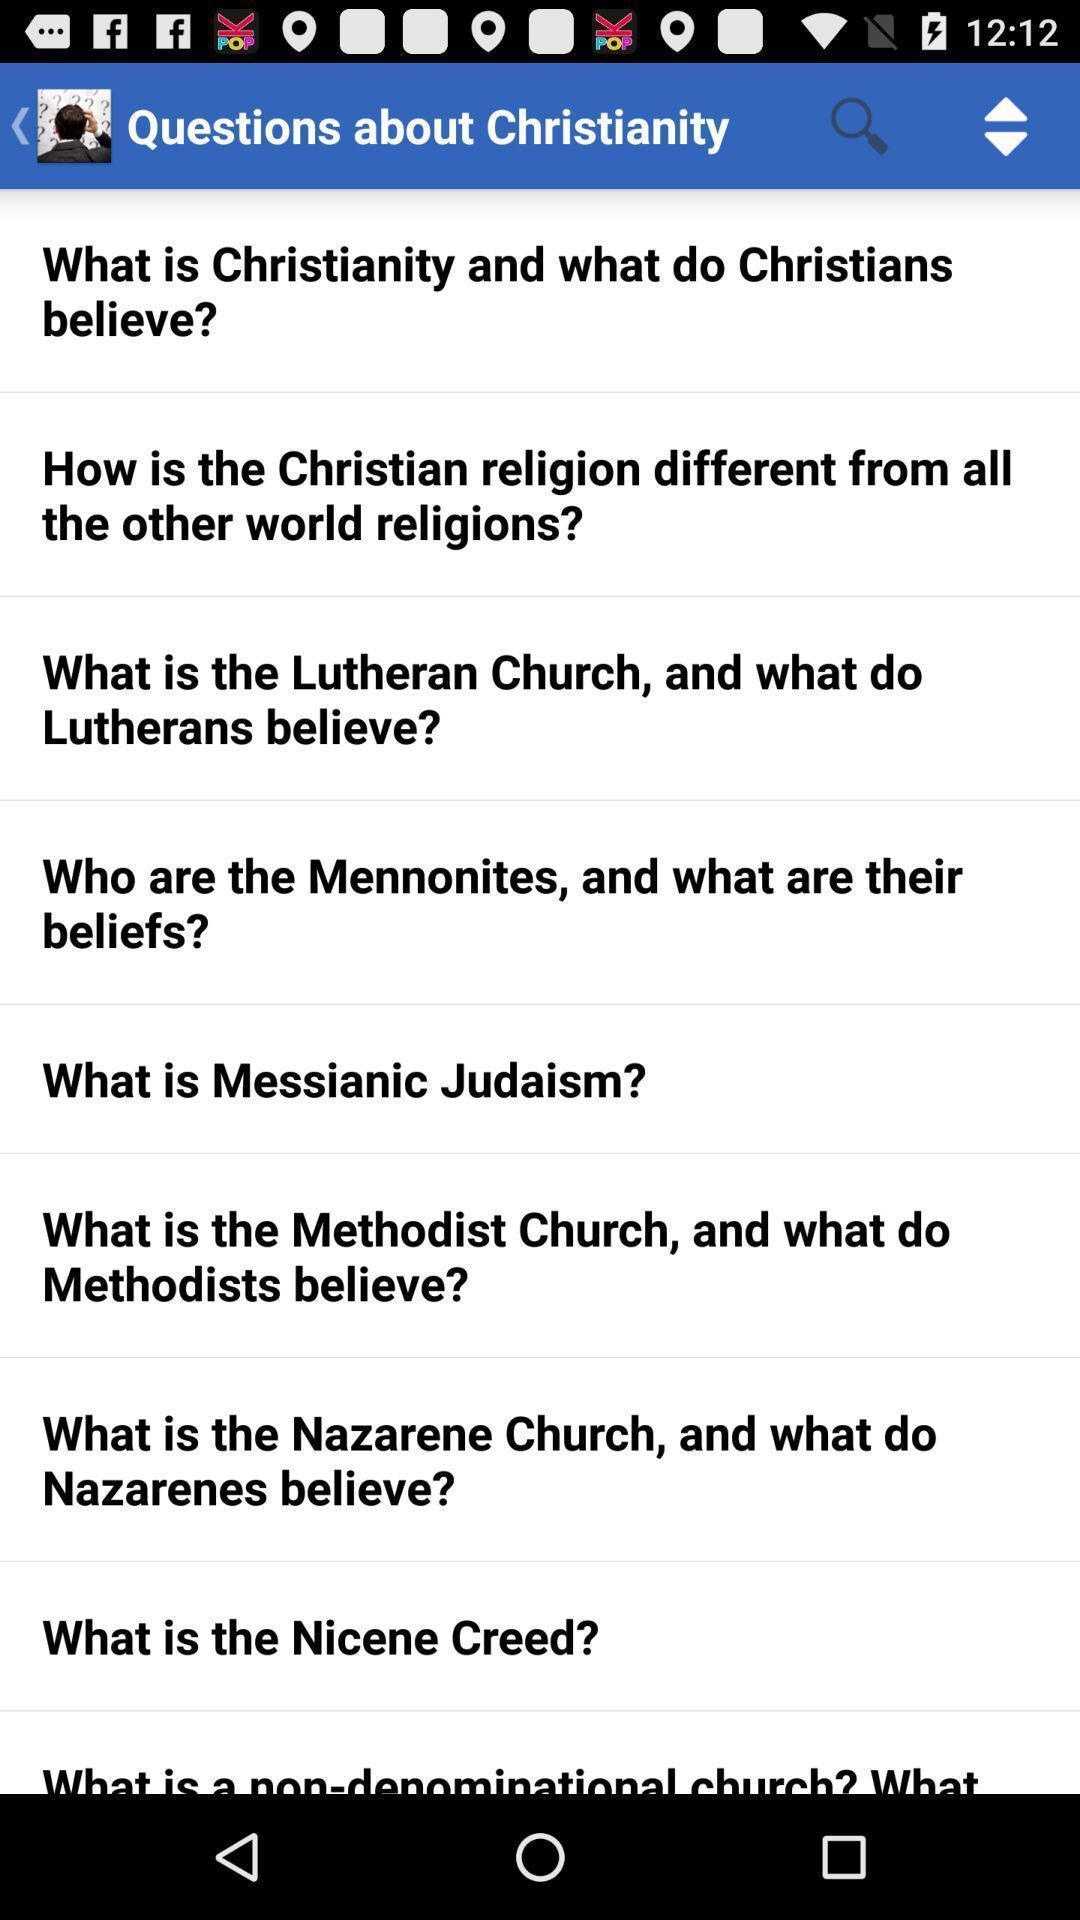What is the overall content of this screenshot? Page is asking the various questions about a christianity. 